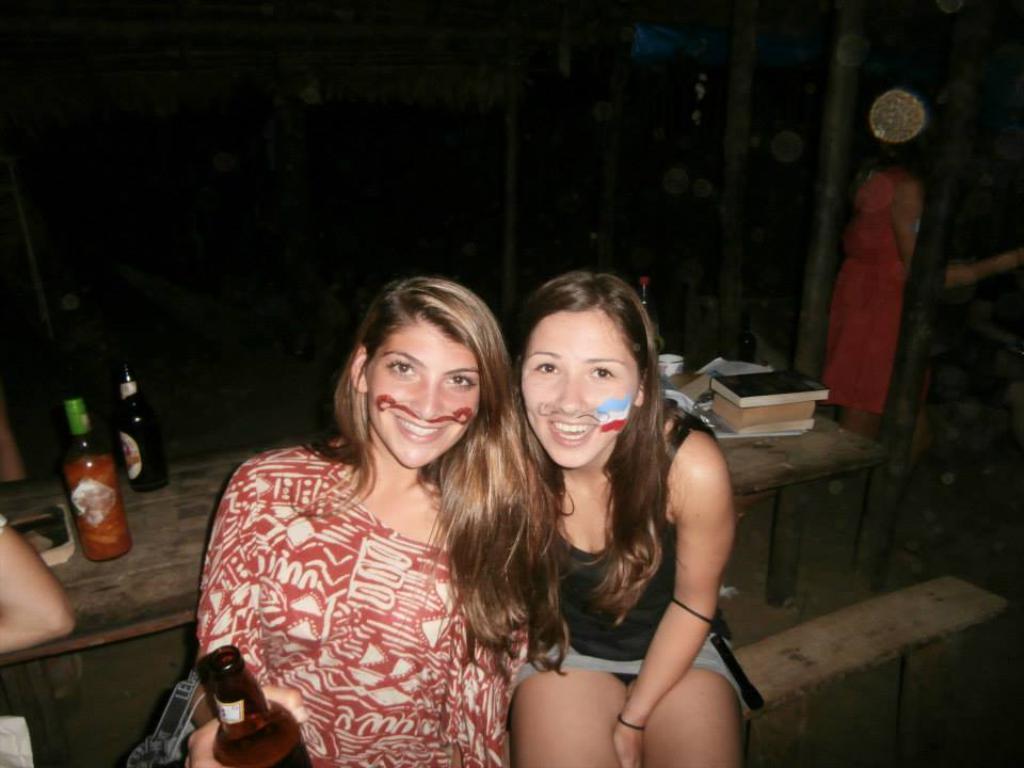How would you summarize this image in a sentence or two? Two women sitting,here there are bottles and books. 